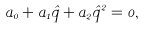<formula> <loc_0><loc_0><loc_500><loc_500>a _ { 0 } + a _ { 1 } \hat { q } + a _ { 2 } \hat { q } ^ { 2 } = 0 ,</formula> 